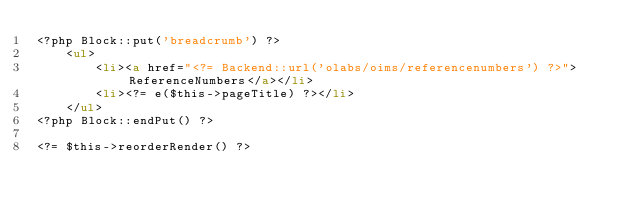Convert code to text. <code><loc_0><loc_0><loc_500><loc_500><_HTML_><?php Block::put('breadcrumb') ?>
    <ul>
        <li><a href="<?= Backend::url('olabs/oims/referencenumbers') ?>">ReferenceNumbers</a></li>
        <li><?= e($this->pageTitle) ?></li>
    </ul>
<?php Block::endPut() ?>

<?= $this->reorderRender() ?></code> 